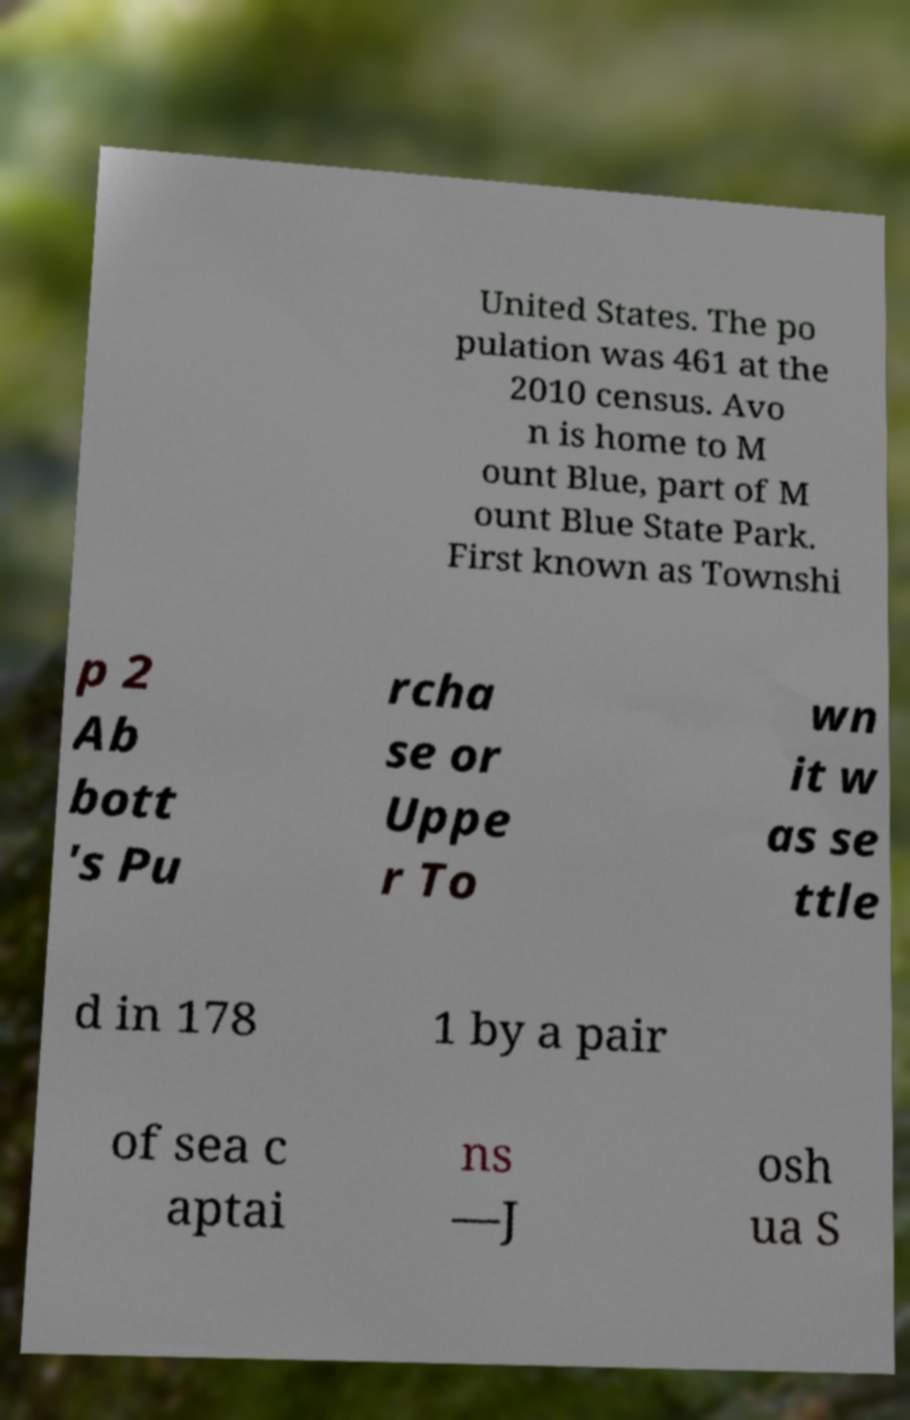There's text embedded in this image that I need extracted. Can you transcribe it verbatim? United States. The po pulation was 461 at the 2010 census. Avo n is home to M ount Blue, part of M ount Blue State Park. First known as Townshi p 2 Ab bott 's Pu rcha se or Uppe r To wn it w as se ttle d in 178 1 by a pair of sea c aptai ns —J osh ua S 